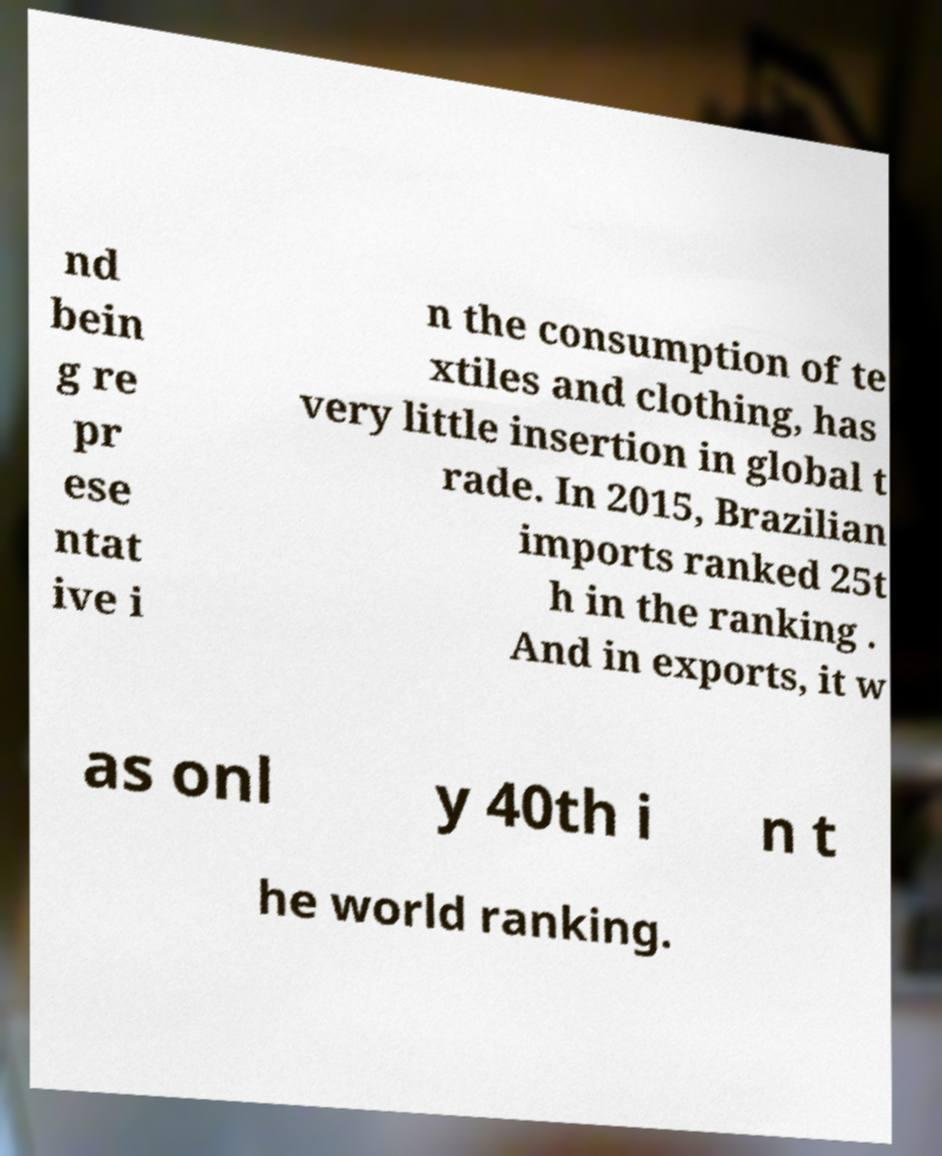Please identify and transcribe the text found in this image. nd bein g re pr ese ntat ive i n the consumption of te xtiles and clothing, has very little insertion in global t rade. In 2015, Brazilian imports ranked 25t h in the ranking . And in exports, it w as onl y 40th i n t he world ranking. 